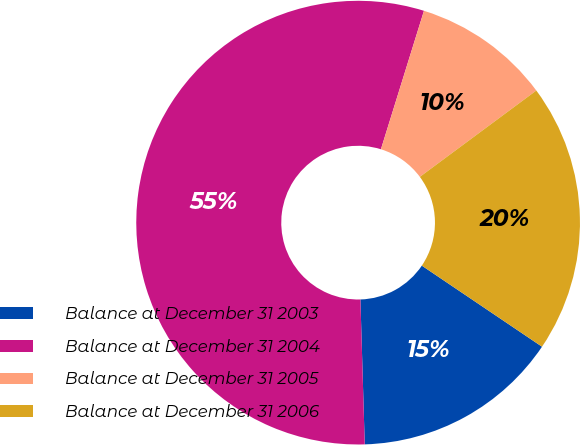Convert chart. <chart><loc_0><loc_0><loc_500><loc_500><pie_chart><fcel>Balance at December 31 2003<fcel>Balance at December 31 2004<fcel>Balance at December 31 2005<fcel>Balance at December 31 2006<nl><fcel>15.08%<fcel>55.28%<fcel>10.05%<fcel>19.6%<nl></chart> 